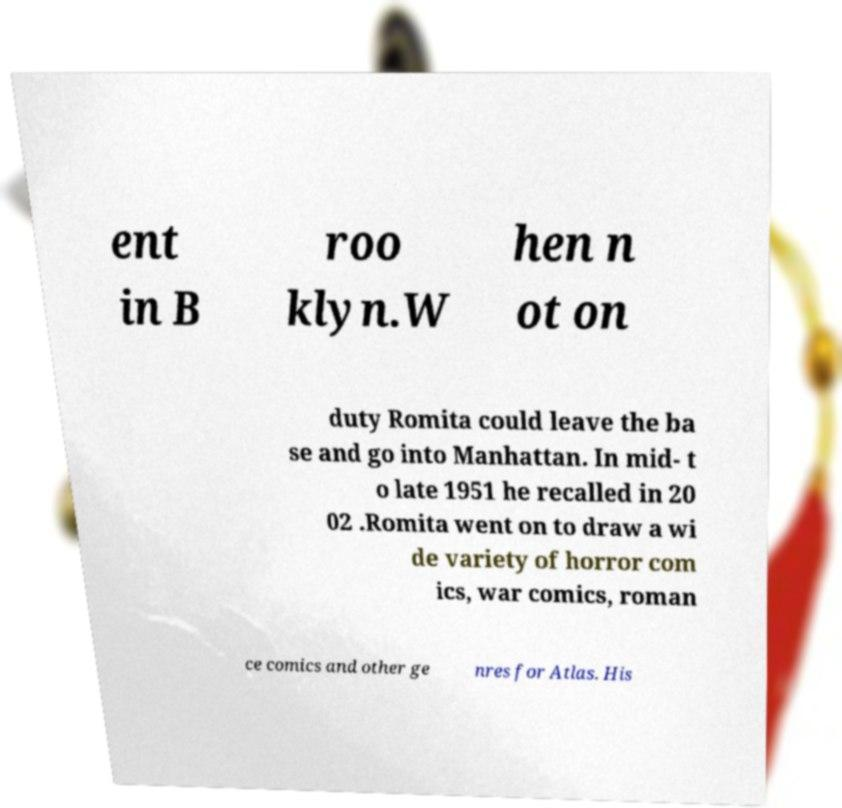There's text embedded in this image that I need extracted. Can you transcribe it verbatim? ent in B roo klyn.W hen n ot on duty Romita could leave the ba se and go into Manhattan. In mid- t o late 1951 he recalled in 20 02 .Romita went on to draw a wi de variety of horror com ics, war comics, roman ce comics and other ge nres for Atlas. His 